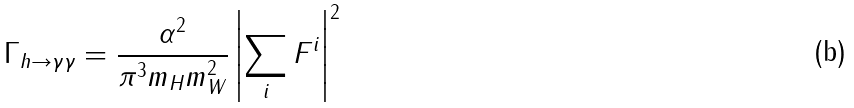<formula> <loc_0><loc_0><loc_500><loc_500>\Gamma _ { h \to \gamma \gamma } = \frac { \alpha ^ { 2 } } { \pi ^ { 3 } m _ { H } m _ { W } ^ { 2 } } \left | \sum _ { i } F ^ { i } \right | ^ { 2 }</formula> 